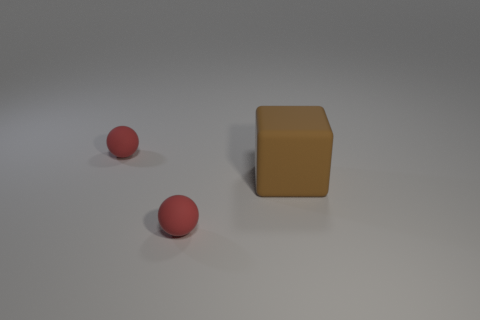Add 1 big brown blocks. How many objects exist? 4 Subtract all cubes. How many objects are left? 2 Subtract all small red balls. Subtract all large brown rubber things. How many objects are left? 0 Add 3 tiny red matte balls. How many tiny red matte balls are left? 5 Add 3 tiny purple blocks. How many tiny purple blocks exist? 3 Subtract 0 cyan cubes. How many objects are left? 3 